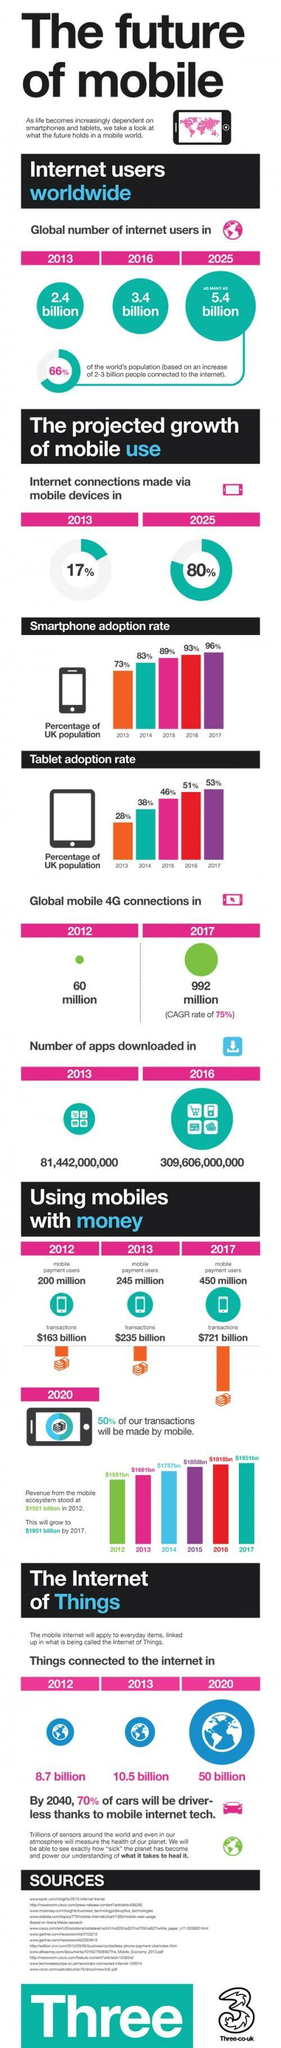What is the average tablet adoption rate from the 2013 to 2017?
Answer the question with a short phrase. 43.2% What the average smartphone adoption rate in the UK from 2013 to 2017? 86.8% What is the percentage increase in internet connections made from 2013 to 2025? 63% What is the increase in mobile connections from 2012 to 2017? 932 million What is the number of apps downloaded during the period 2012 to 2016? 228,164,000,000 What is the estimated growth in the global number of internet users from 2013 to 2025? 3 million What is the difference in the number of things connected to the internet from 2012 to 2020? 41.3 billion What was the total value of transaction that took place in 2012, 2013 and 2017 ? 1,119 billion 